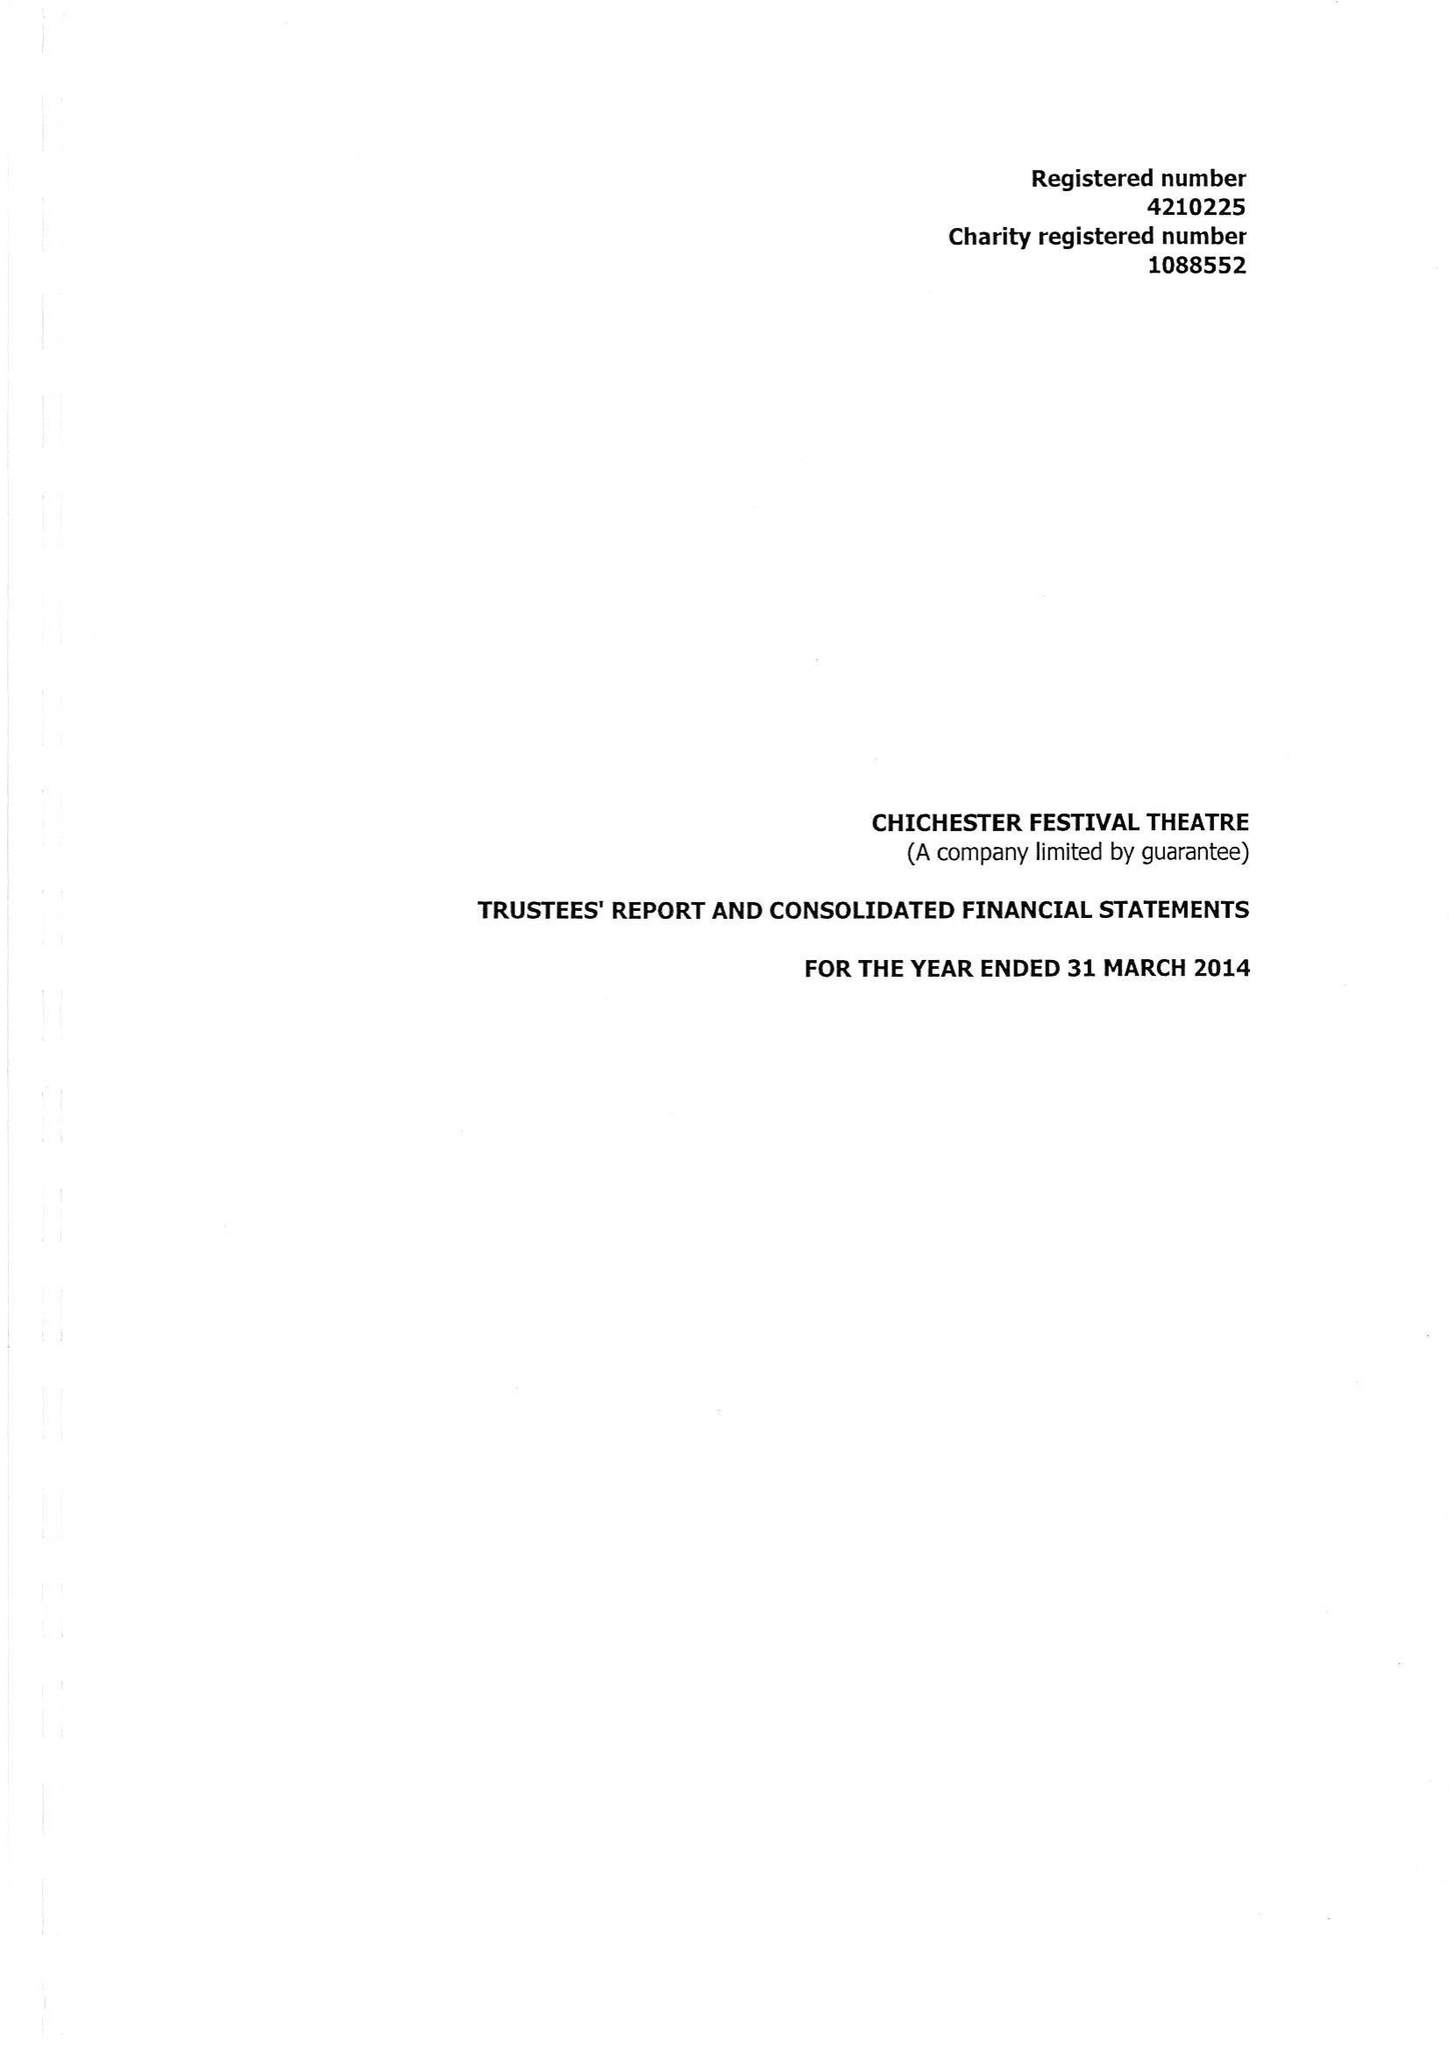What is the value for the spending_annually_in_british_pounds?
Answer the question using a single word or phrase. 12394627.00 